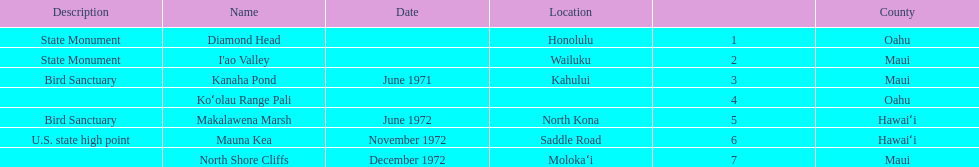How many dates are in 1972? 3. 